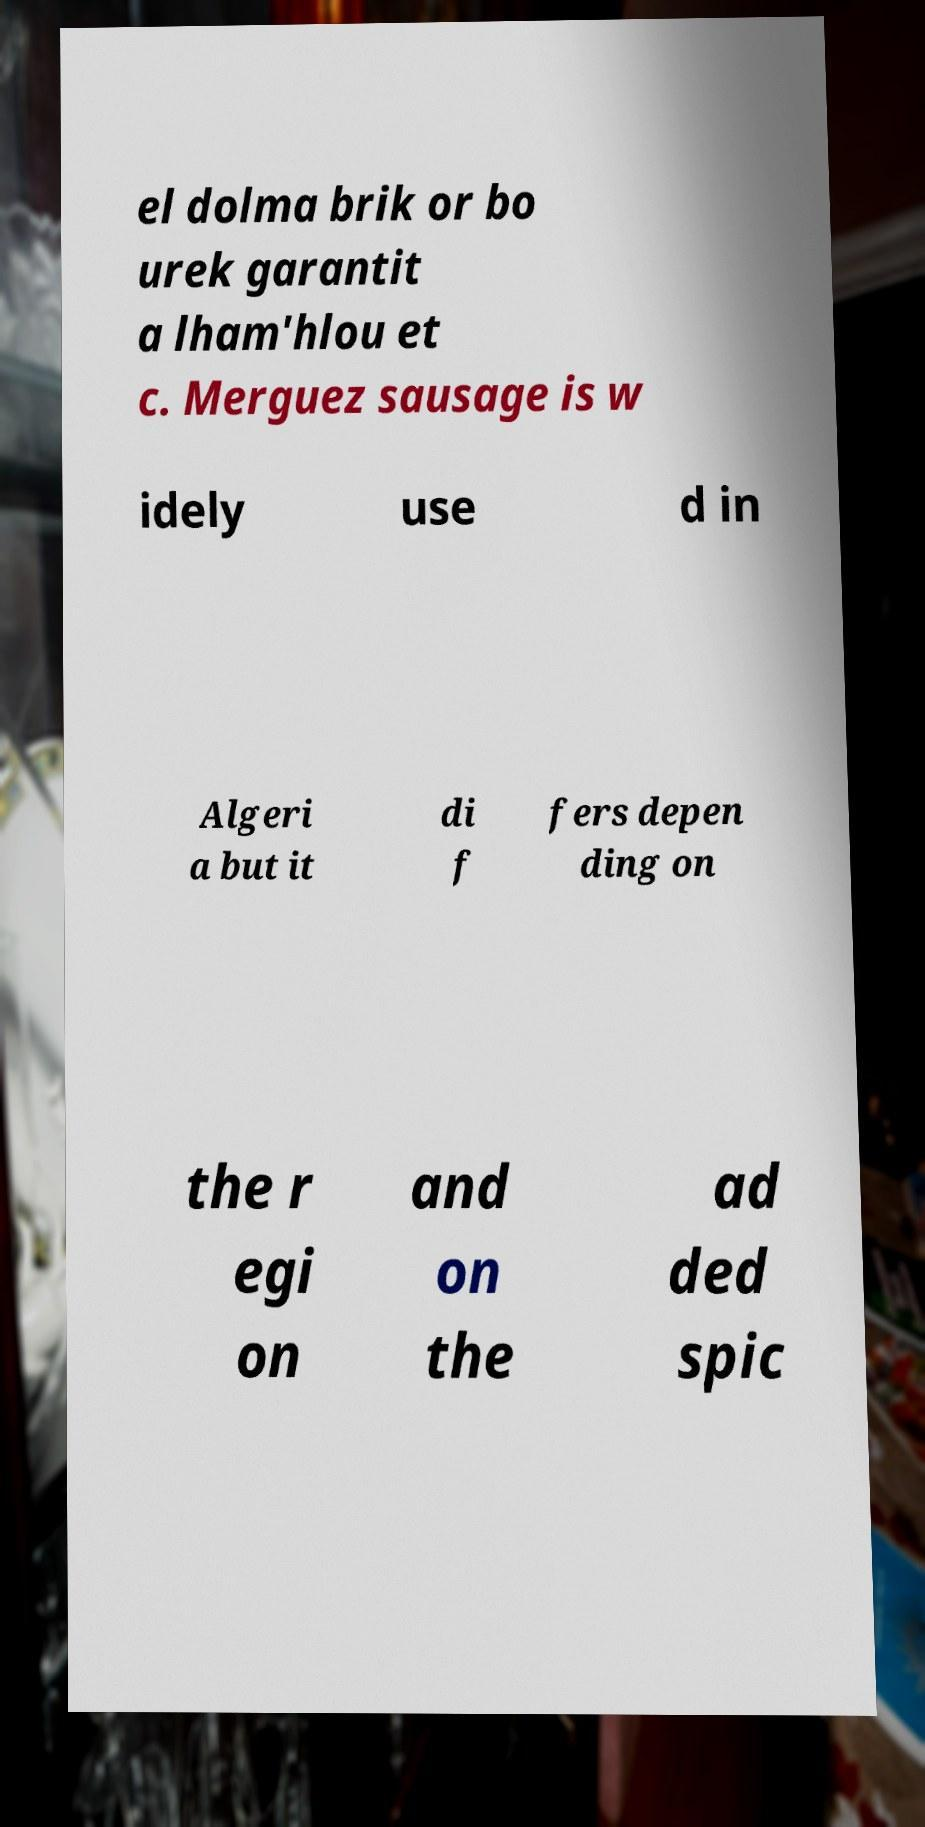Can you read and provide the text displayed in the image?This photo seems to have some interesting text. Can you extract and type it out for me? el dolma brik or bo urek garantit a lham'hlou et c. Merguez sausage is w idely use d in Algeri a but it di f fers depen ding on the r egi on and on the ad ded spic 